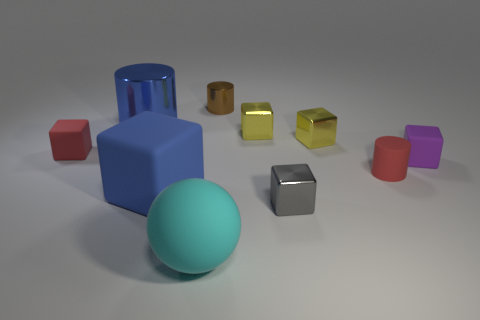What number of red objects are there?
Provide a succinct answer. 2. What number of small red things are on the left side of the large cyan rubber object and right of the matte sphere?
Provide a succinct answer. 0. What material is the gray block?
Your answer should be very brief. Metal. Are any tiny blue cylinders visible?
Provide a succinct answer. No. What color is the small rubber cube that is on the right side of the blue metal cylinder?
Your response must be concise. Purple. There is a large thing that is behind the red rubber thing that is on the right side of the large metal cylinder; what number of metallic cylinders are left of it?
Provide a short and direct response. 0. What is the object that is both in front of the big cube and to the right of the tiny brown metal object made of?
Provide a succinct answer. Metal. Is the material of the brown object the same as the red thing on the right side of the large rubber ball?
Your answer should be very brief. No. Are there more tiny red rubber objects that are to the right of the purple matte object than tiny purple matte things that are in front of the small gray metallic cube?
Give a very brief answer. No. The small brown thing is what shape?
Your response must be concise. Cylinder. 